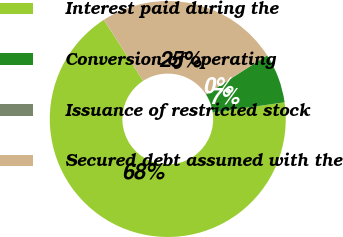Convert chart. <chart><loc_0><loc_0><loc_500><loc_500><pie_chart><fcel>Interest paid during the<fcel>Conversion of operating<fcel>Issuance of restricted stock<fcel>Secured debt assumed with the<nl><fcel>68.14%<fcel>6.81%<fcel>0.0%<fcel>25.05%<nl></chart> 